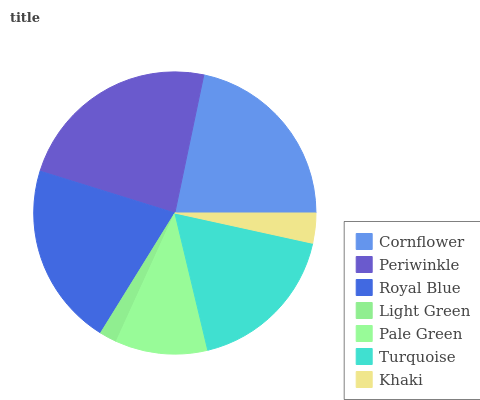Is Light Green the minimum?
Answer yes or no. Yes. Is Periwinkle the maximum?
Answer yes or no. Yes. Is Royal Blue the minimum?
Answer yes or no. No. Is Royal Blue the maximum?
Answer yes or no. No. Is Periwinkle greater than Royal Blue?
Answer yes or no. Yes. Is Royal Blue less than Periwinkle?
Answer yes or no. Yes. Is Royal Blue greater than Periwinkle?
Answer yes or no. No. Is Periwinkle less than Royal Blue?
Answer yes or no. No. Is Turquoise the high median?
Answer yes or no. Yes. Is Turquoise the low median?
Answer yes or no. Yes. Is Periwinkle the high median?
Answer yes or no. No. Is Pale Green the low median?
Answer yes or no. No. 